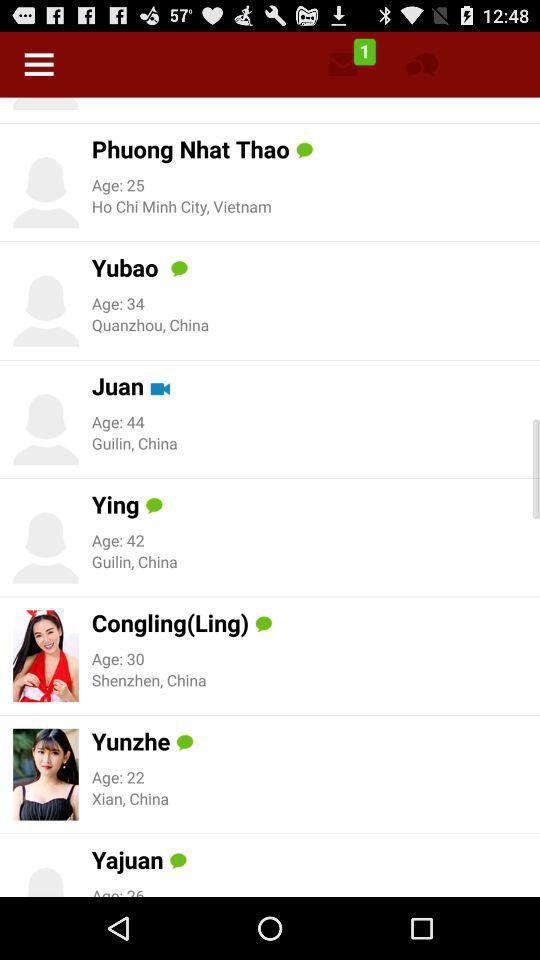Who is available for a video call? The user who is available for a video call is "Juan". 